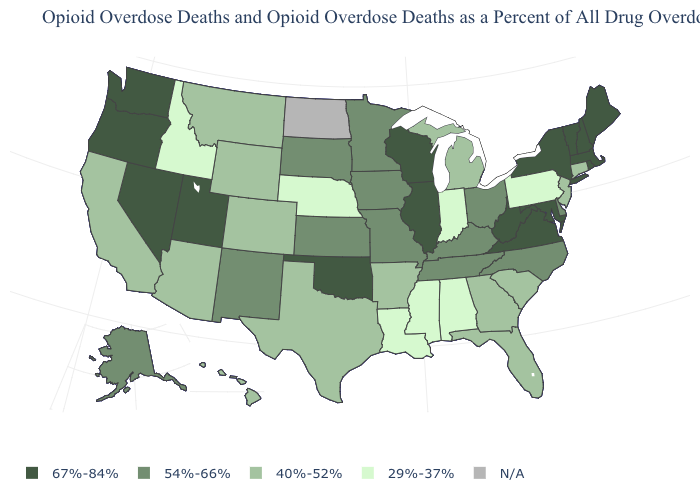How many symbols are there in the legend?
Answer briefly. 5. What is the highest value in the Northeast ?
Keep it brief. 67%-84%. What is the highest value in the USA?
Answer briefly. 67%-84%. Is the legend a continuous bar?
Be succinct. No. What is the value of Colorado?
Write a very short answer. 40%-52%. Does the map have missing data?
Be succinct. Yes. How many symbols are there in the legend?
Keep it brief. 5. What is the value of Maine?
Keep it brief. 67%-84%. Name the states that have a value in the range 40%-52%?
Answer briefly. Arizona, Arkansas, California, Colorado, Connecticut, Florida, Georgia, Hawaii, Michigan, Montana, New Jersey, South Carolina, Texas, Wyoming. What is the value of Tennessee?
Write a very short answer. 54%-66%. Among the states that border North Dakota , which have the lowest value?
Answer briefly. Montana. What is the highest value in the MidWest ?
Concise answer only. 67%-84%. Does the map have missing data?
Answer briefly. Yes. What is the value of Michigan?
Concise answer only. 40%-52%. 